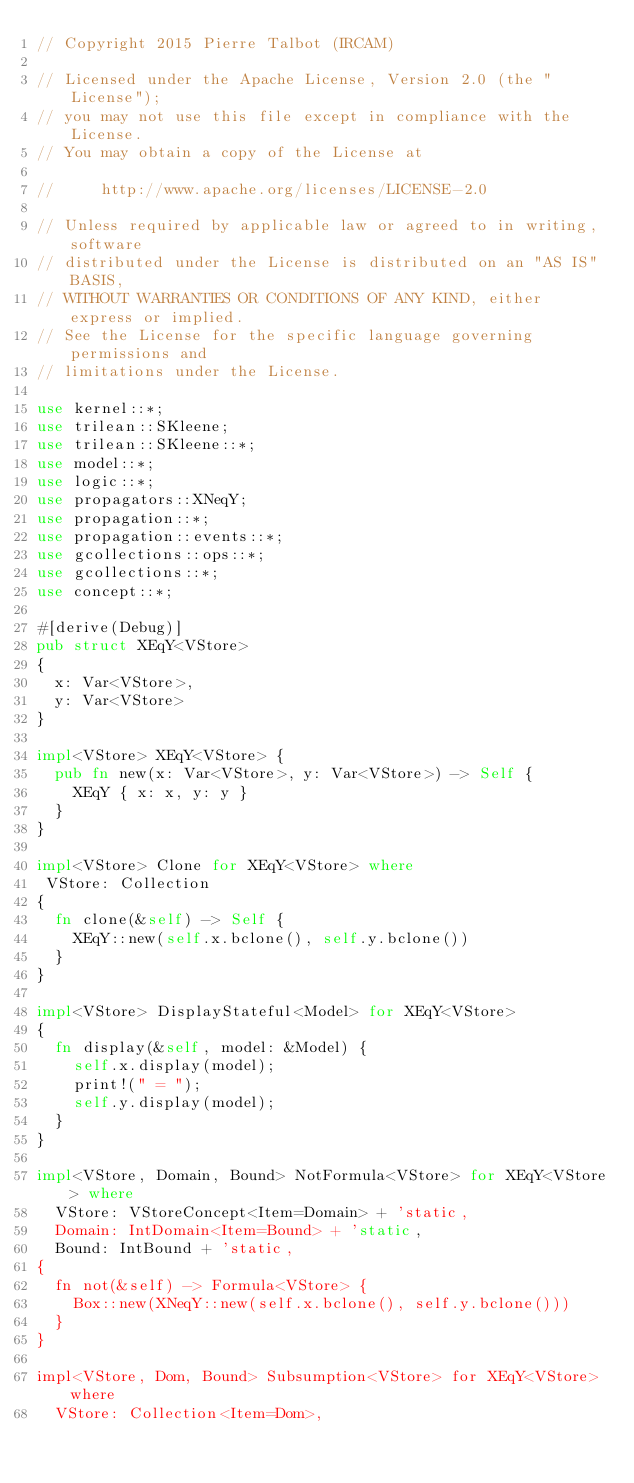Convert code to text. <code><loc_0><loc_0><loc_500><loc_500><_Rust_>// Copyright 2015 Pierre Talbot (IRCAM)

// Licensed under the Apache License, Version 2.0 (the "License");
// you may not use this file except in compliance with the License.
// You may obtain a copy of the License at

//     http://www.apache.org/licenses/LICENSE-2.0

// Unless required by applicable law or agreed to in writing, software
// distributed under the License is distributed on an "AS IS" BASIS,
// WITHOUT WARRANTIES OR CONDITIONS OF ANY KIND, either express or implied.
// See the License for the specific language governing permissions and
// limitations under the License.

use kernel::*;
use trilean::SKleene;
use trilean::SKleene::*;
use model::*;
use logic::*;
use propagators::XNeqY;
use propagation::*;
use propagation::events::*;
use gcollections::ops::*;
use gcollections::*;
use concept::*;

#[derive(Debug)]
pub struct XEqY<VStore>
{
  x: Var<VStore>,
  y: Var<VStore>
}

impl<VStore> XEqY<VStore> {
  pub fn new(x: Var<VStore>, y: Var<VStore>) -> Self {
    XEqY { x: x, y: y }
  }
}

impl<VStore> Clone for XEqY<VStore> where
 VStore: Collection
{
  fn clone(&self) -> Self {
    XEqY::new(self.x.bclone(), self.y.bclone())
  }
}

impl<VStore> DisplayStateful<Model> for XEqY<VStore>
{
  fn display(&self, model: &Model) {
    self.x.display(model);
    print!(" = ");
    self.y.display(model);
  }
}

impl<VStore, Domain, Bound> NotFormula<VStore> for XEqY<VStore> where
  VStore: VStoreConcept<Item=Domain> + 'static,
  Domain: IntDomain<Item=Bound> + 'static,
  Bound: IntBound + 'static,
{
  fn not(&self) -> Formula<VStore> {
    Box::new(XNeqY::new(self.x.bclone(), self.y.bclone()))
  }
}

impl<VStore, Dom, Bound> Subsumption<VStore> for XEqY<VStore> where
  VStore: Collection<Item=Dom>,</code> 